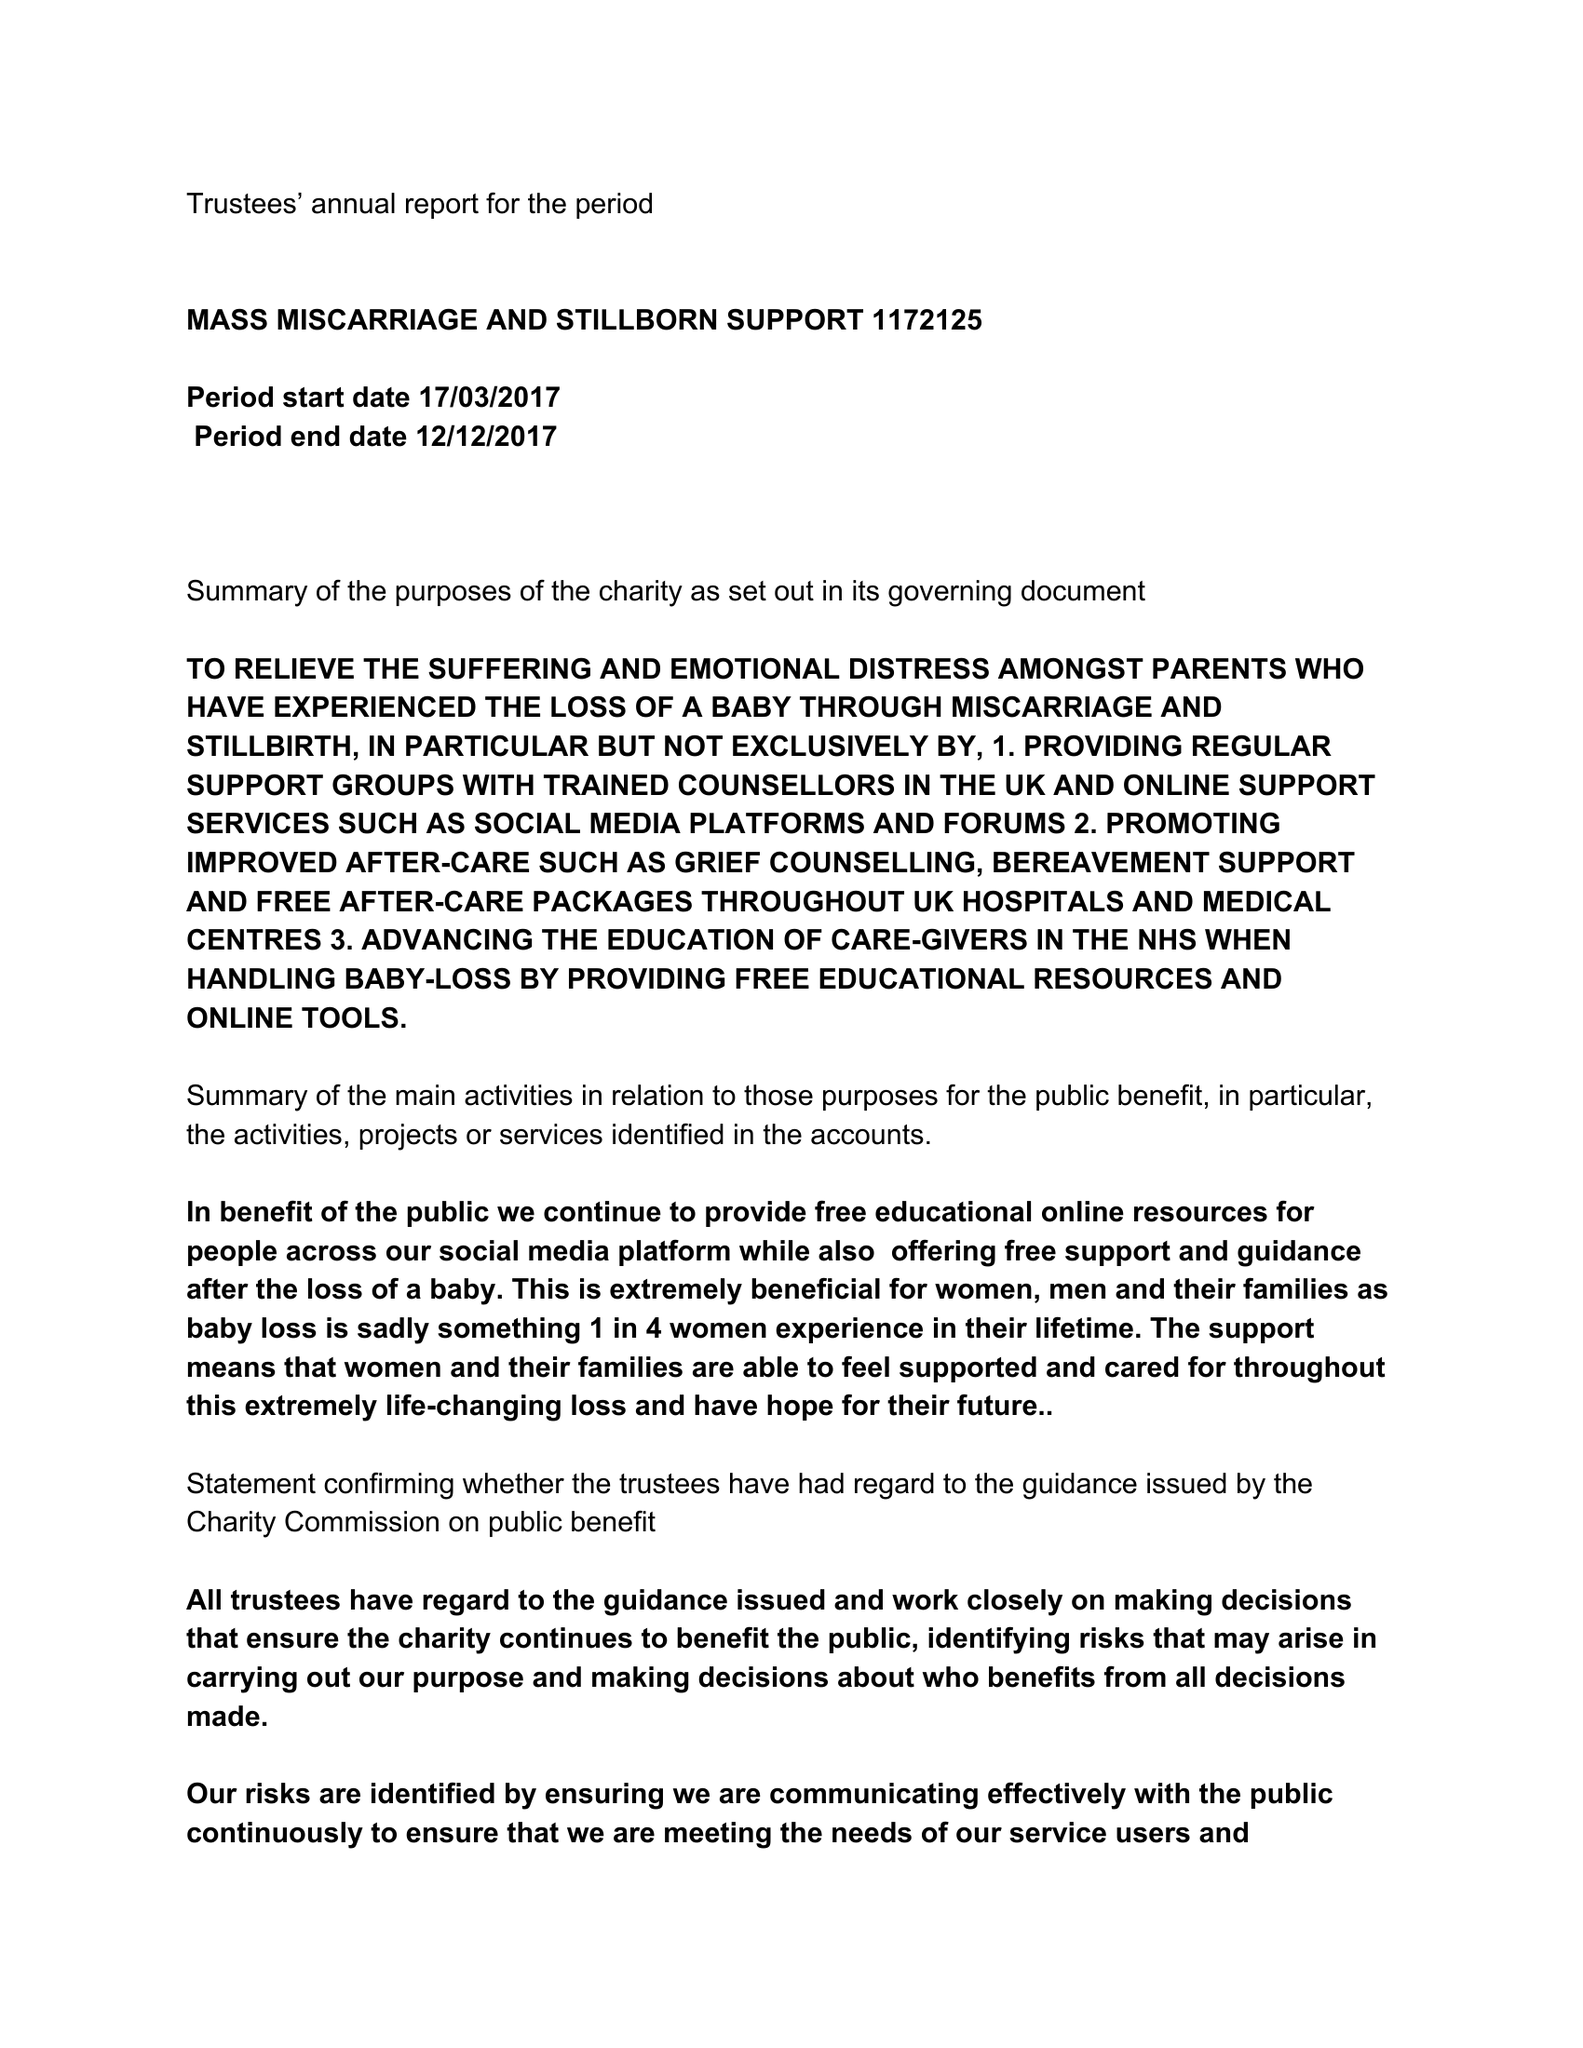What is the value for the spending_annually_in_british_pounds?
Answer the question using a single word or phrase. None 